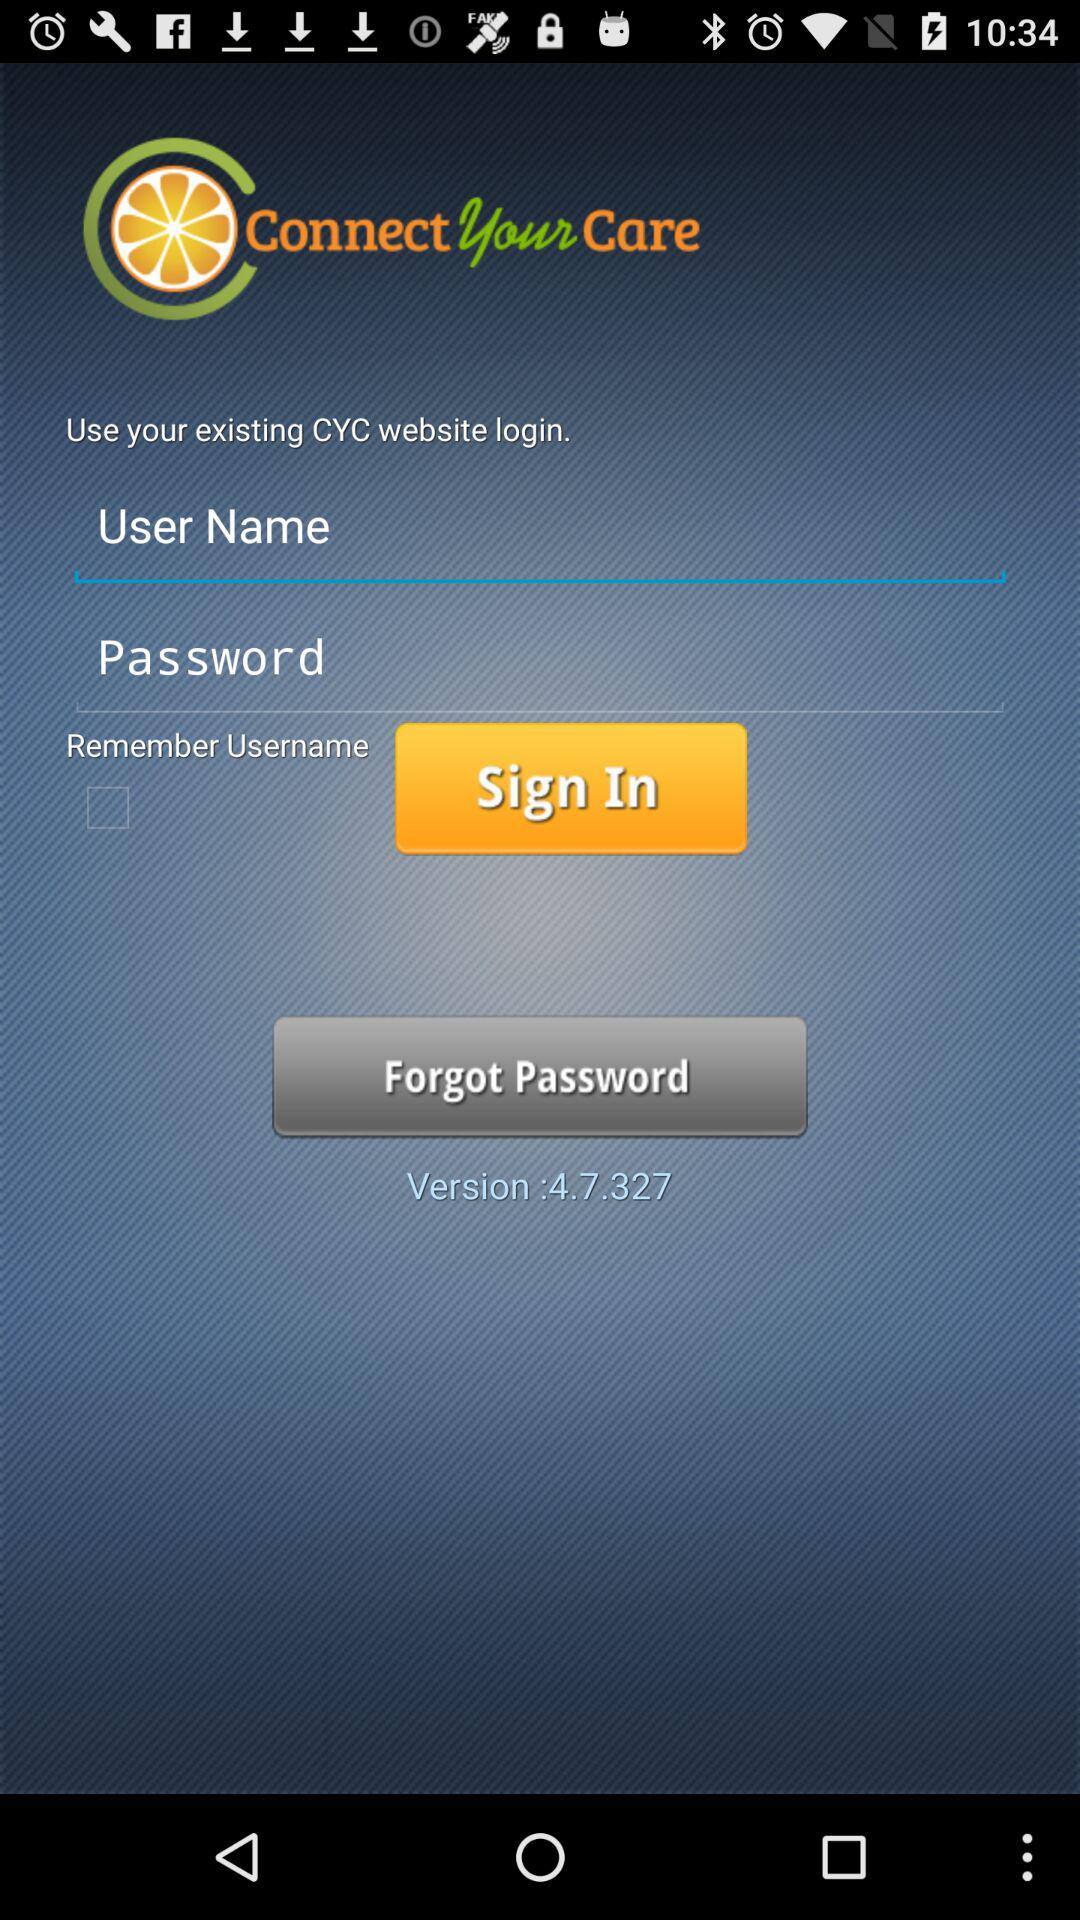What is the version of the application? The version of the application is 4.7.327. 